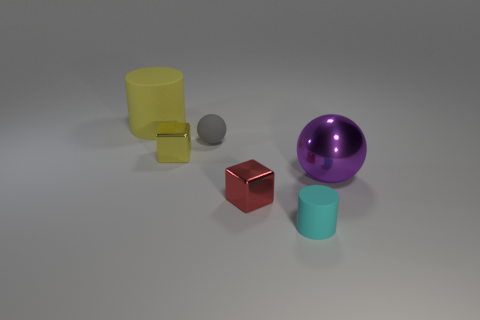Subtract all red blocks. How many blocks are left? 1 Subtract all cylinders. How many objects are left? 4 Subtract 2 cylinders. How many cylinders are left? 0 Subtract all cyan cylinders. Subtract all purple spheres. How many cylinders are left? 1 Subtract all red cylinders. How many purple spheres are left? 1 Subtract all purple metal objects. Subtract all big yellow matte things. How many objects are left? 4 Add 1 big things. How many big things are left? 3 Add 6 big purple balls. How many big purple balls exist? 7 Add 1 tiny shiny balls. How many objects exist? 7 Subtract 0 yellow balls. How many objects are left? 6 